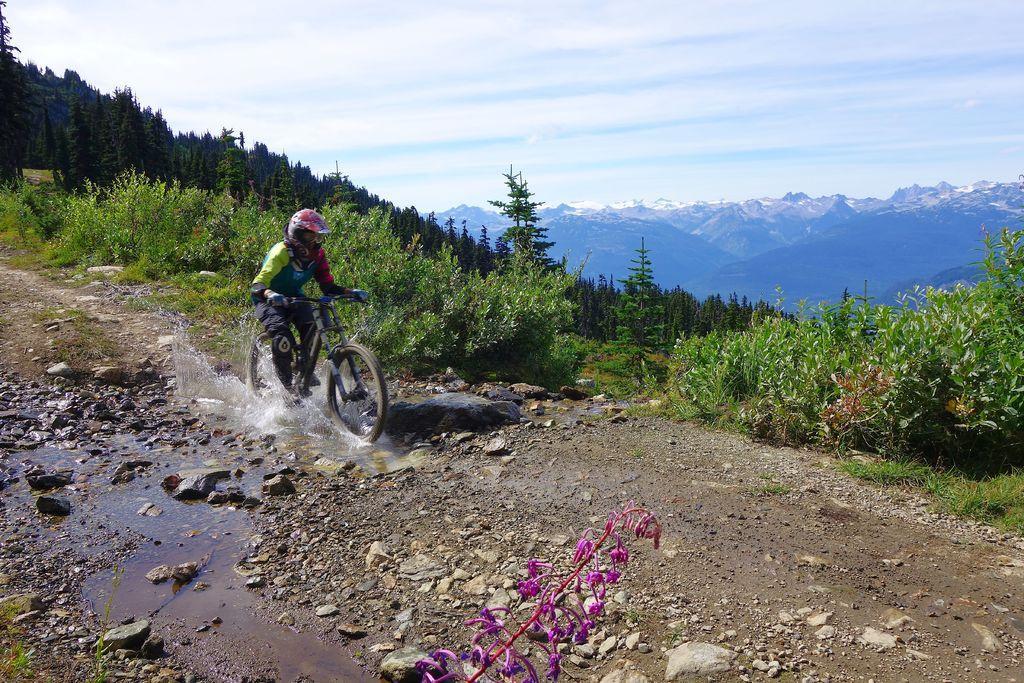How would you summarize this image in a sentence or two? In this picture we can see a person is riding bicycle and the person wore a helmet, and we can see water, few rocks and trees, in the background we can see hills and clouds. 